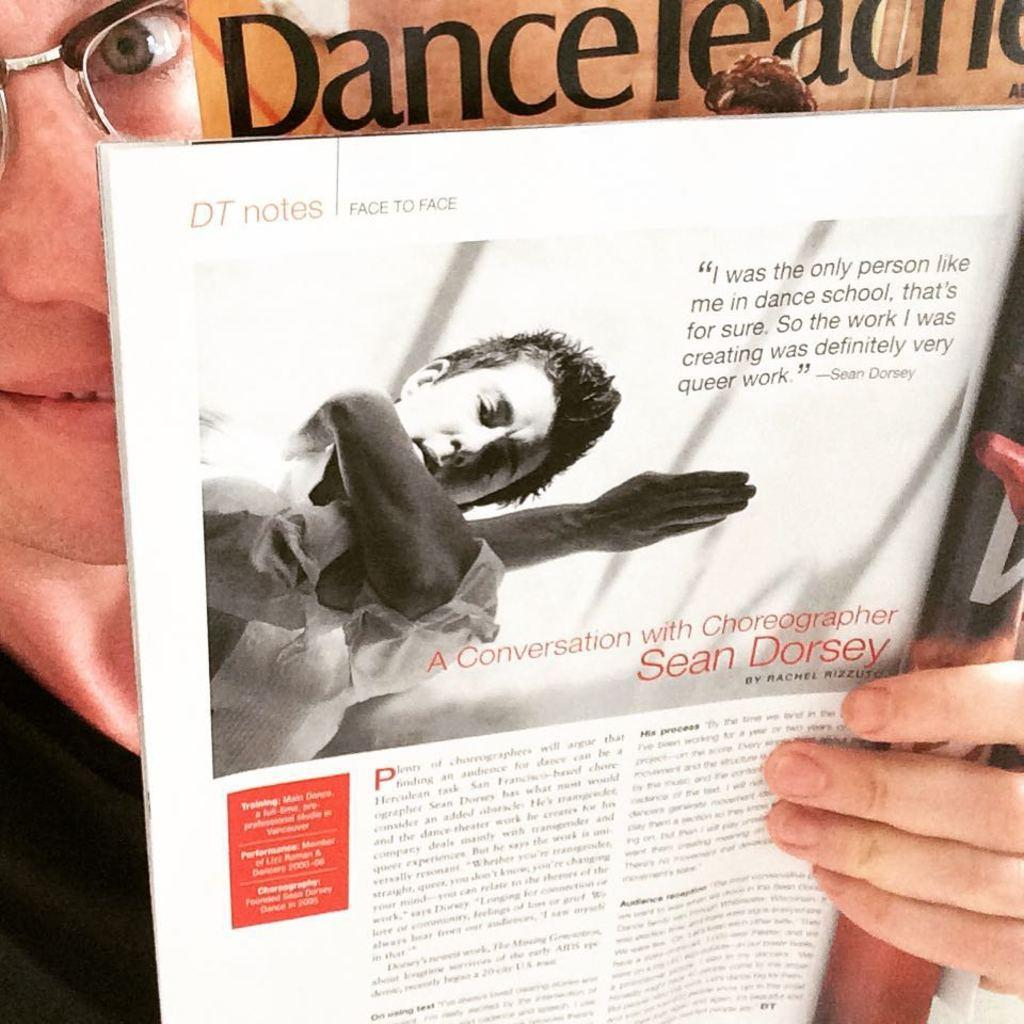<image>
Present a compact description of the photo's key features. A man holding up the article A Conversation with Choreographer Sean Dorsey. 